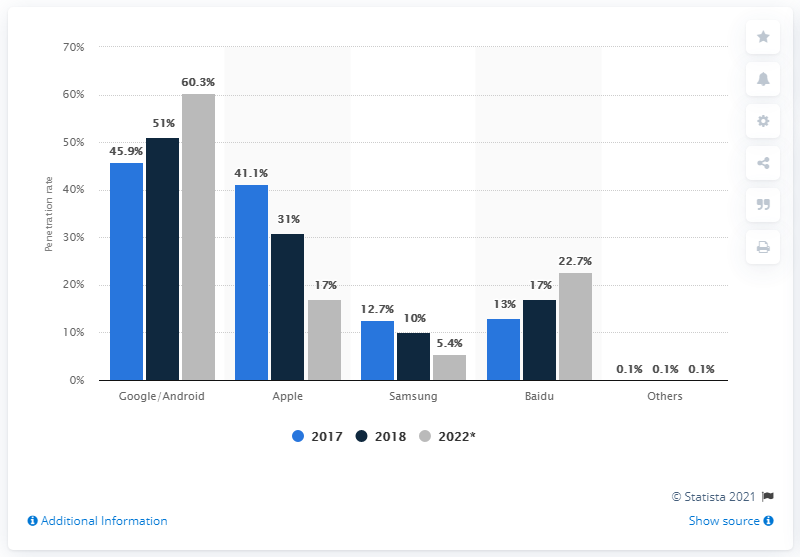Mention a couple of crucial points in this snapshot. The sum total of the brand Apple and Samsung in the year 2017 was 53.8. According to the data available for the year 2022, Google/Android has the highest penetration rate among all brands. 